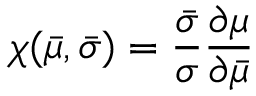Convert formula to latex. <formula><loc_0><loc_0><loc_500><loc_500>\chi ( \bar { \mu } , \bar { \sigma } ) = \frac { \bar { \sigma } } { \sigma } \frac { \partial \mu } { \partial \bar { \mu } }</formula> 